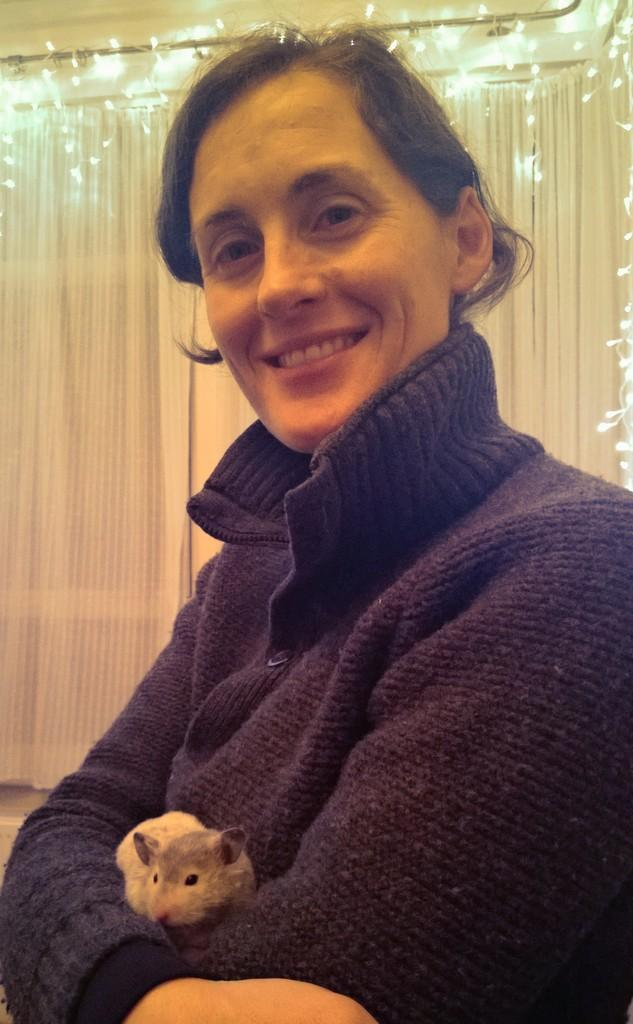Who is present in the image? There is a woman in the image. What is the woman wearing? The woman is wearing a sweater. What is the woman holding in her hands? The woman is holding a rat in her hands. What can be seen in the background of the image? There is a white color curtain and lights visible in the background. What object is present in the background that supports the curtain? There is a rod in the background. What type of plastic beam can be seen supporting the station in the image? There is no station or plastic beam present in the image. 